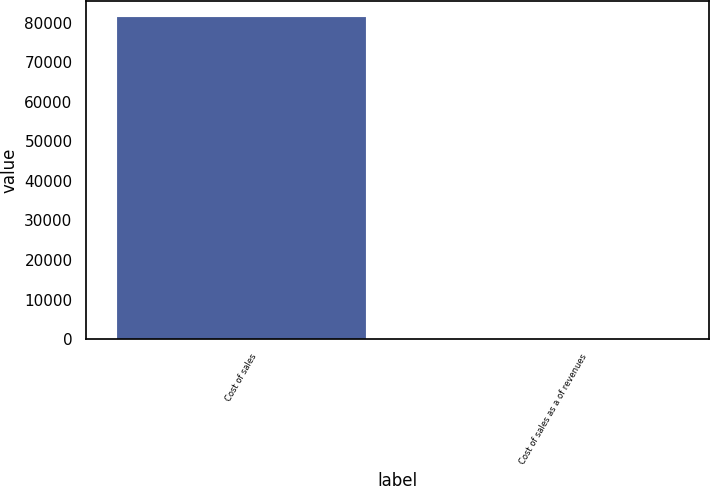Convert chart. <chart><loc_0><loc_0><loc_500><loc_500><bar_chart><fcel>Cost of sales<fcel>Cost of sales as a of revenues<nl><fcel>81490<fcel>80.6<nl></chart> 